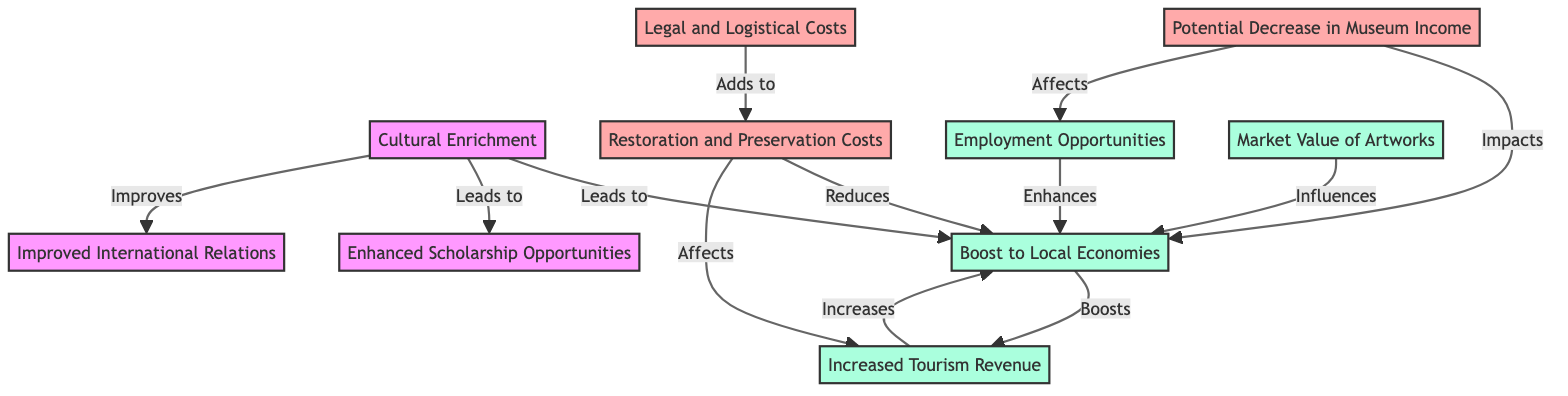What is the primary outcome of cultural enrichment? The primary outcome of cultural enrichment is a boost to local economies, as indicated by the arrow leading from cultural enrichment to that node.
Answer: Boost to Local Economies How many cost-related nodes are identified in the diagram? The diagram highlights three cost-related nodes: restoration and preservation costs, potential decrease in museum income, and legal and logistical costs. By counting these nodes, we find the total.
Answer: Three What node is impacted by both restoration and preservation costs and potential decrease in museum income? Both restoration and preservation costs and potential decrease in museum income impact the node representing boosting local economies, as shown by the arrows pointing to that node.
Answer: Boost to Local Economies Which node leads to improved international relations? The node that leads to improved international relations is cultural enrichment, indicated by the arrow pointing from cultural enrichment to improved international relations.
Answer: Cultural Enrichment What economic implication is enhanced by legal and logistical costs? Legal and logistical costs add to the restoration and preservation costs, which in turn reduce the boosting of local economies according to the directional relationships depicted in the diagram.
Answer: Restoration and Preservation Costs How does enhanced scholarship opportunities relate to cultural enrichment? Enhanced scholarship opportunities are a result of cultural enrichment, as depicted in the diagram by the relationship where cultural enrichment leads to enhanced scholarship opportunities.
Answer: Enhanced Scholarship Opportunities What is the effect of employment opportunities on the local economy? Employment opportunities enhance the local economy, as there's a connection from employment opportunities to boosting local economies in the diagram.
Answer: Boost to Local Economies Which factor influences the market value of artworks? The market value of artworks is influenced by the boost to local economies, shown by the arrow stemming from boost to local economies to market value of artworks.
Answer: Boost to Local Economies 